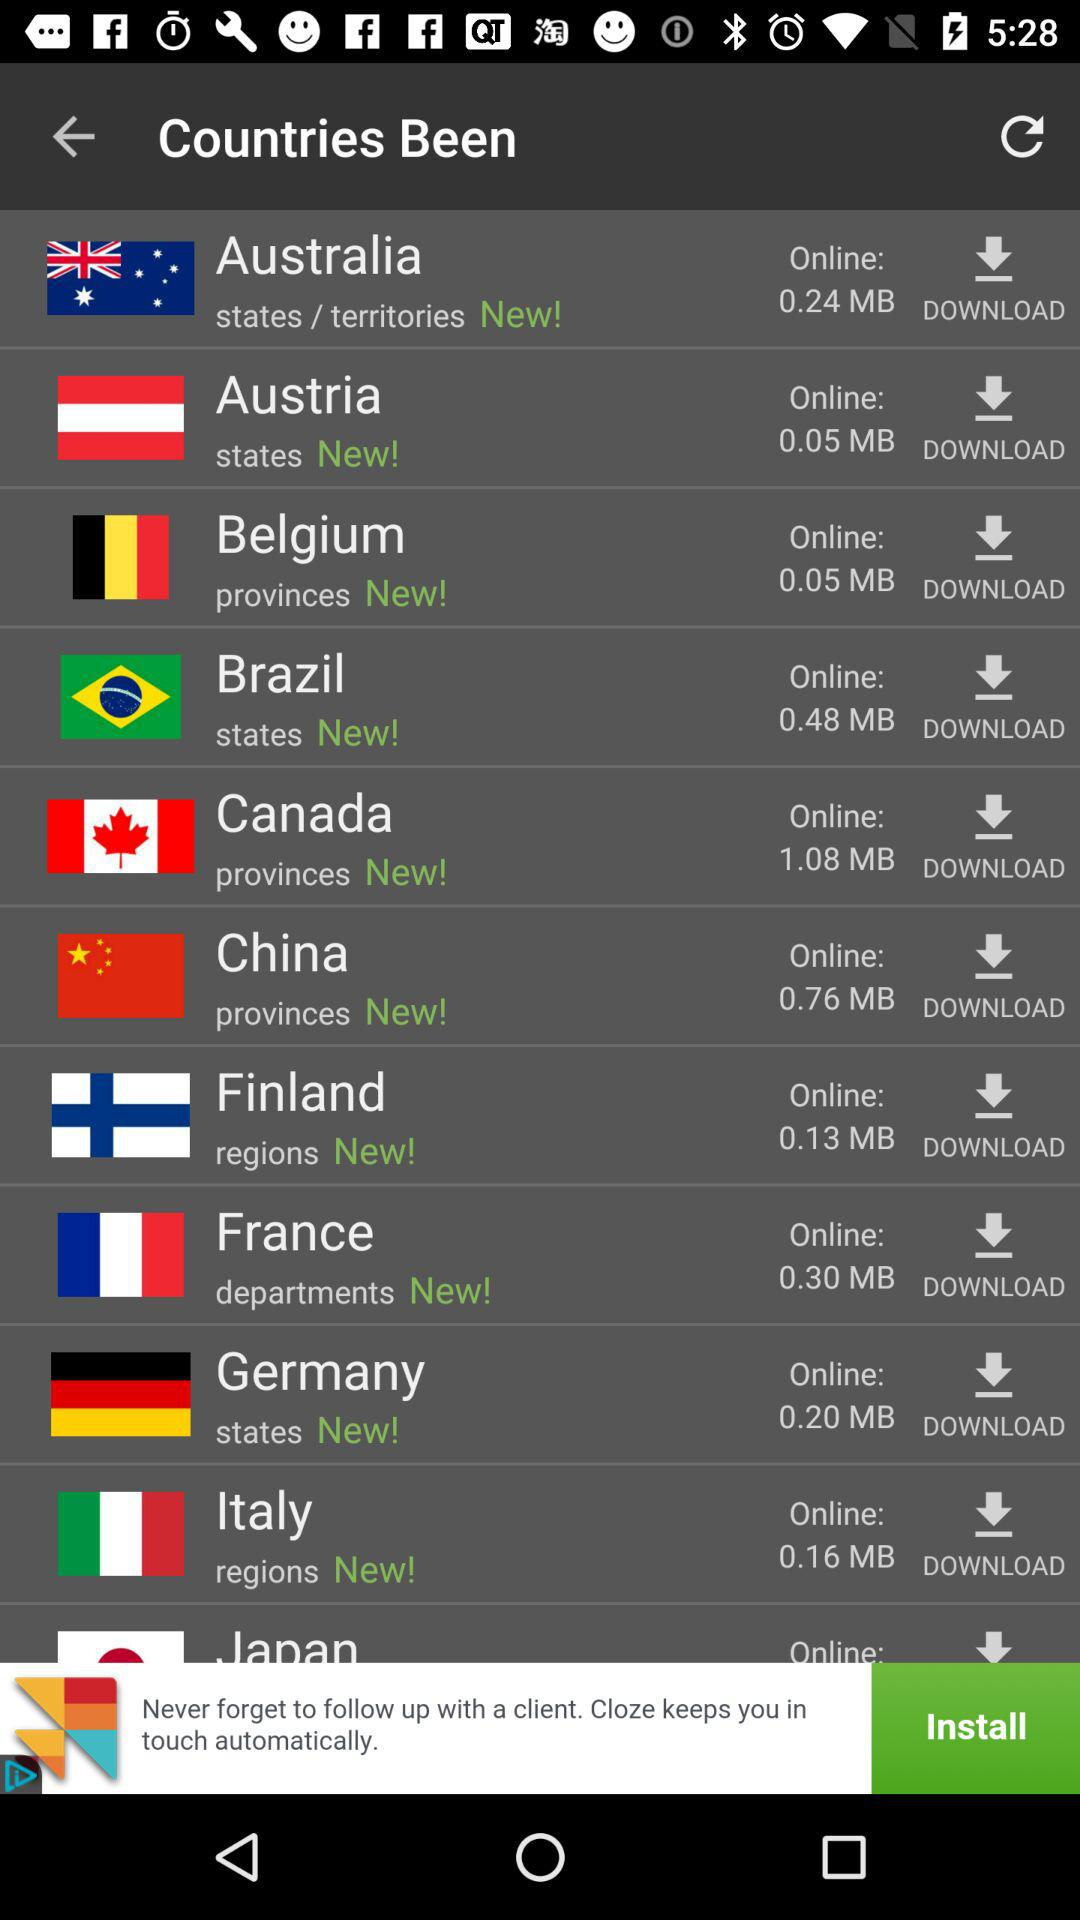For which country has the size of 0.20 MB been mentioned? The size of 0.20 MB has been mentioned for Germany. 